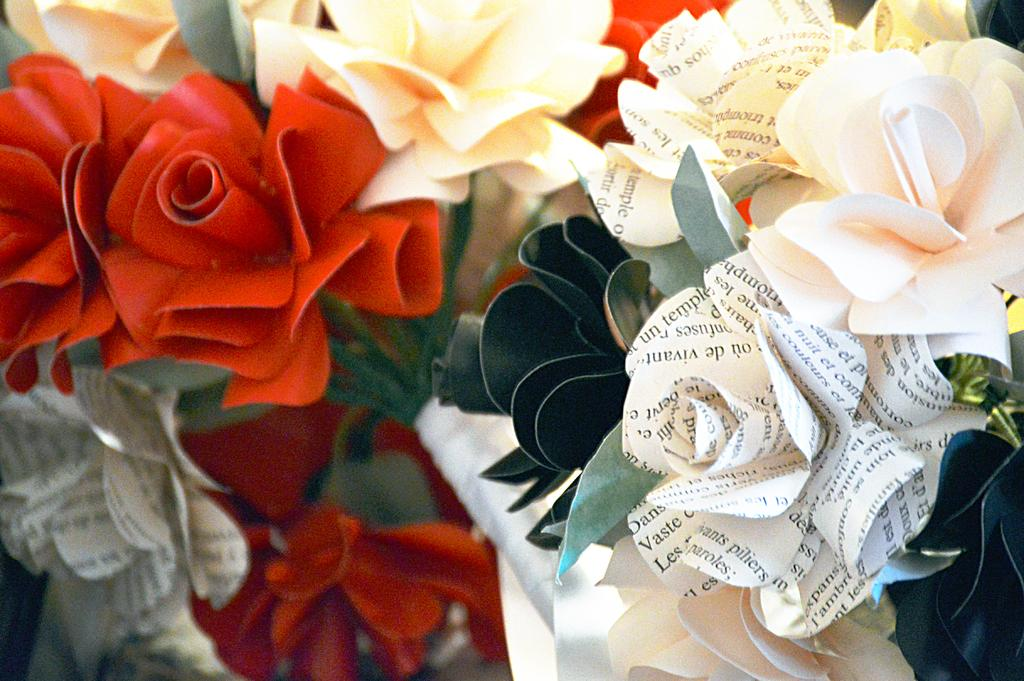What type of flowers are present in the image? There are many paper flowers in the image. Can you describe the appearance of the paper flowers? The paper flowers are colorful. Where is the basket of nuts located in the image? There is no basket of nuts present in the image; it only features many colorful paper flowers. 